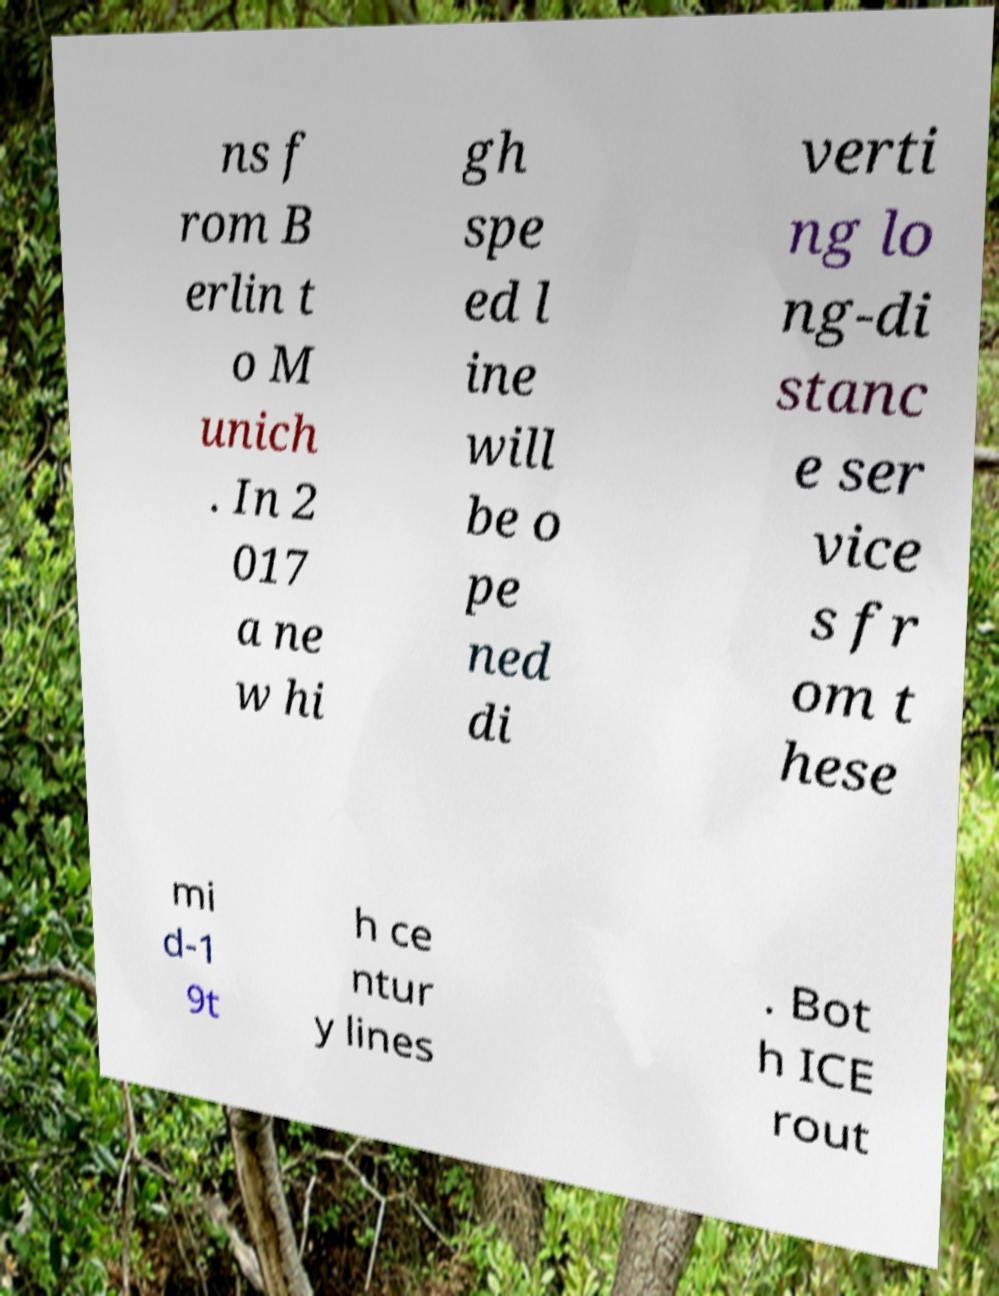I need the written content from this picture converted into text. Can you do that? ns f rom B erlin t o M unich . In 2 017 a ne w hi gh spe ed l ine will be o pe ned di verti ng lo ng-di stanc e ser vice s fr om t hese mi d-1 9t h ce ntur y lines . Bot h ICE rout 